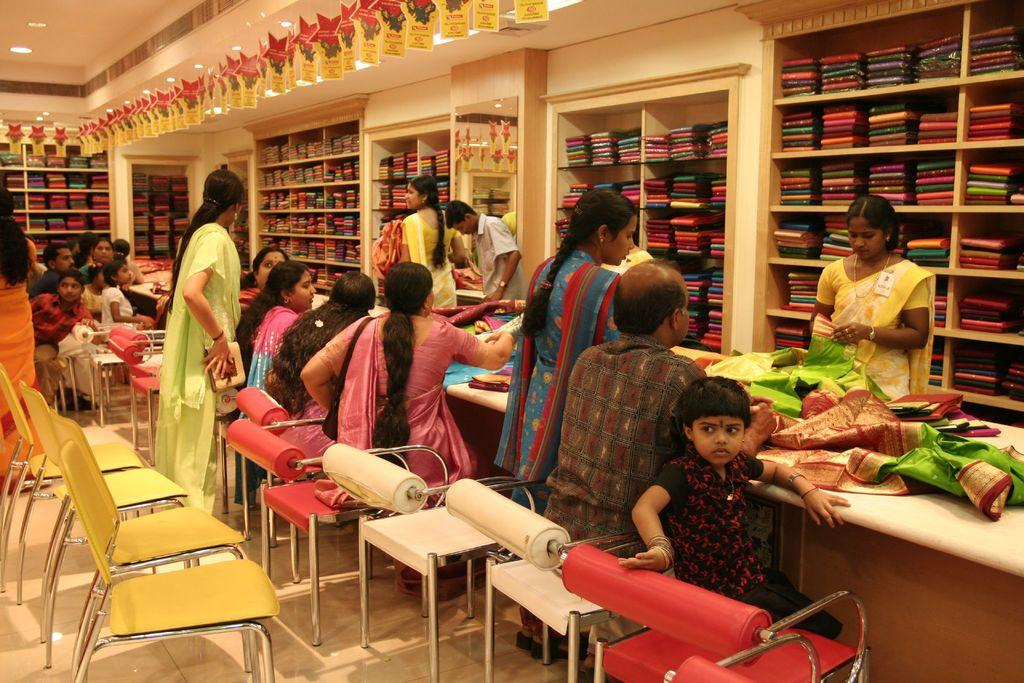How many people are in the image? There are people in the image, but the exact number is not specified. What are some of the people doing in the image? Some of the people are sitting, and some are standing. What can be seen in the background of the image? There are clothes on racks and lights visible in the background. What type of lipstick is the robin wearing in the image? There is no robin or lipstick present in the image. What rule is being enforced by the people in the image? The facts provided do not mention any rules or enforcement, so we cannot determine if any rules are being enforced in the image. 